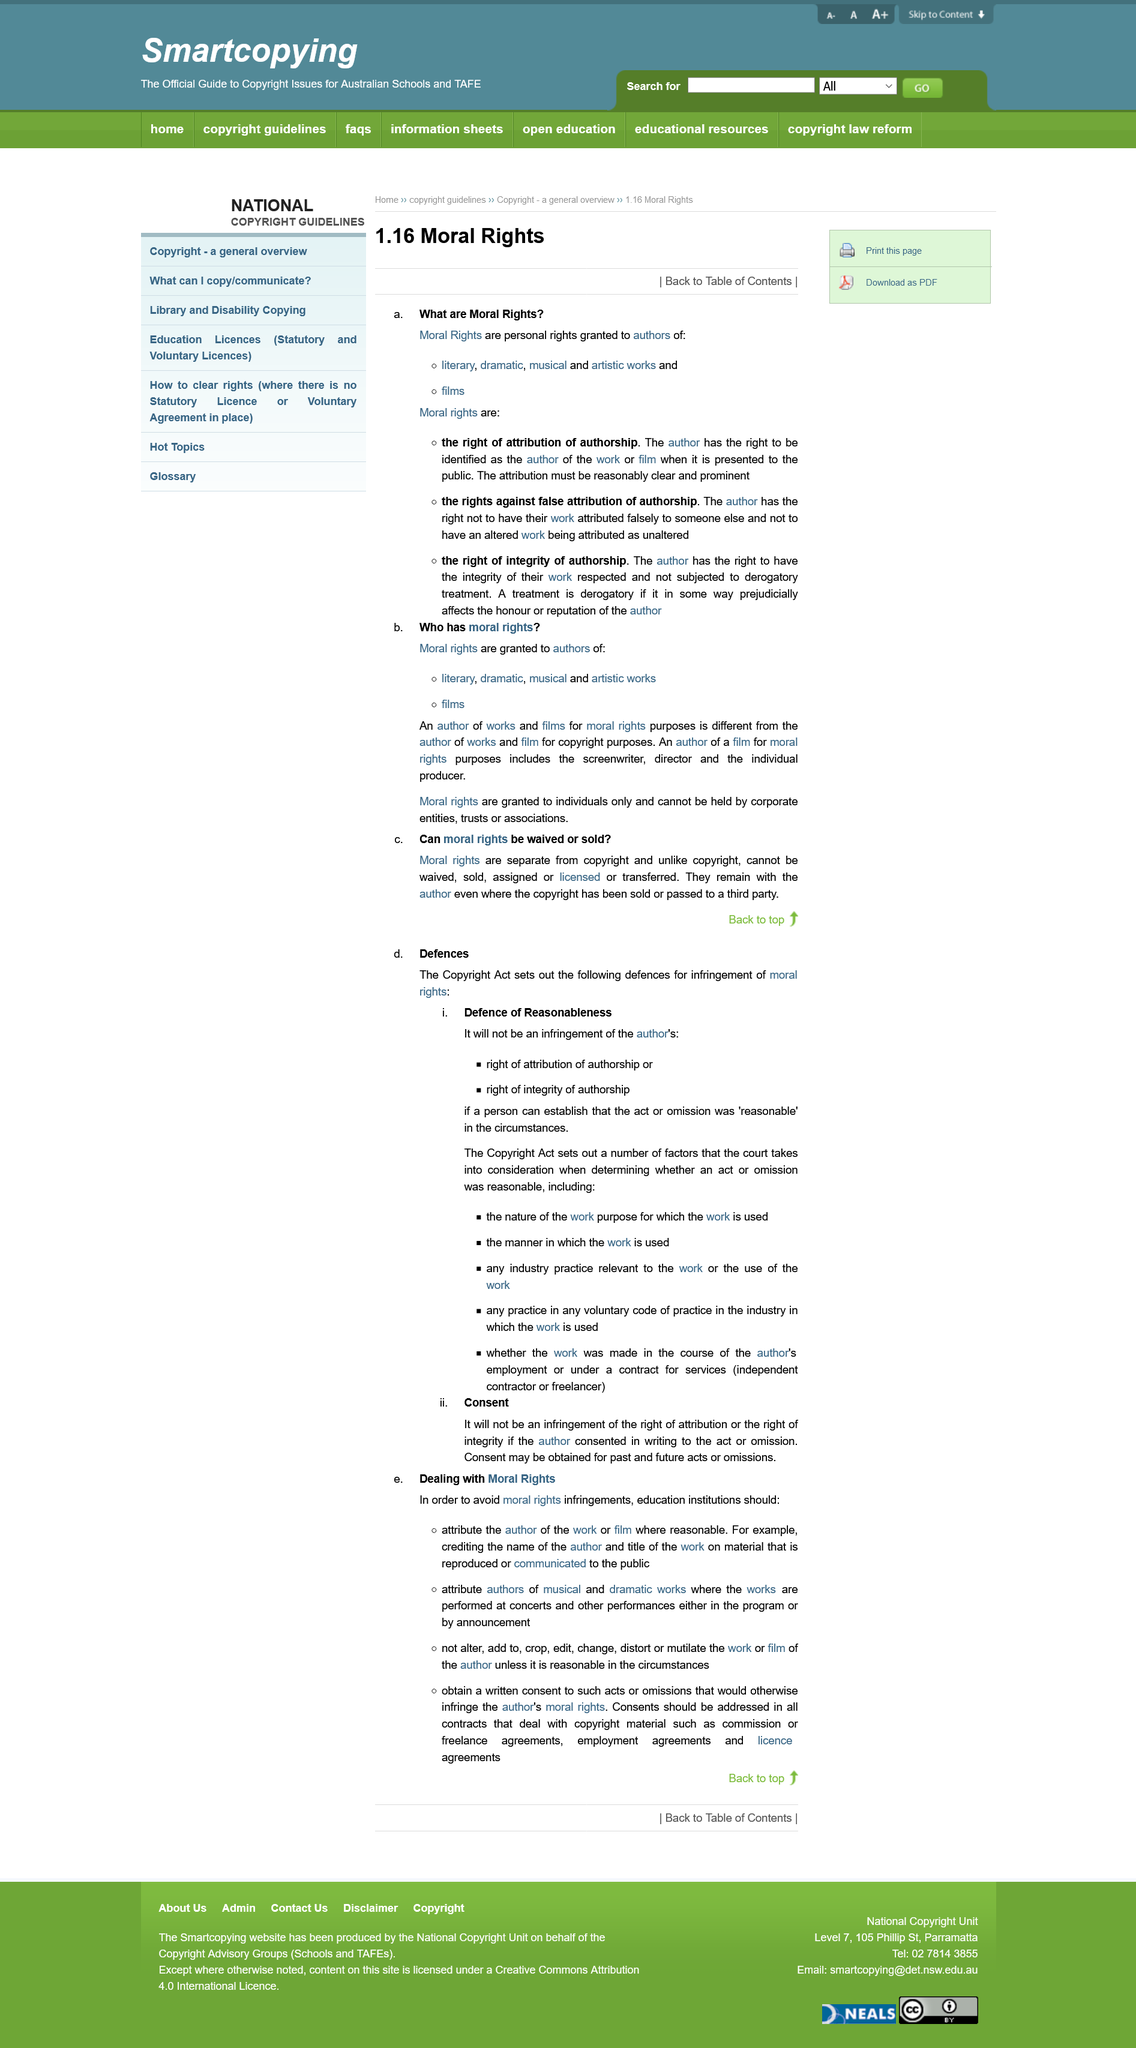Specify some key components in this picture. It is potentially a moral rights infringement for an education institution to edit a work or film. It is recommended to credit the name of the author and the title of the work in order to attribute the author of a film accurately. Yes, the attribution of authorship needs to be prominently displayed. It is necessary to attribute the author of a musical work for a performance at a concert by either including it in the program or making an announcement before the performance. Yes, Moral Rights are granted to authors of films. 